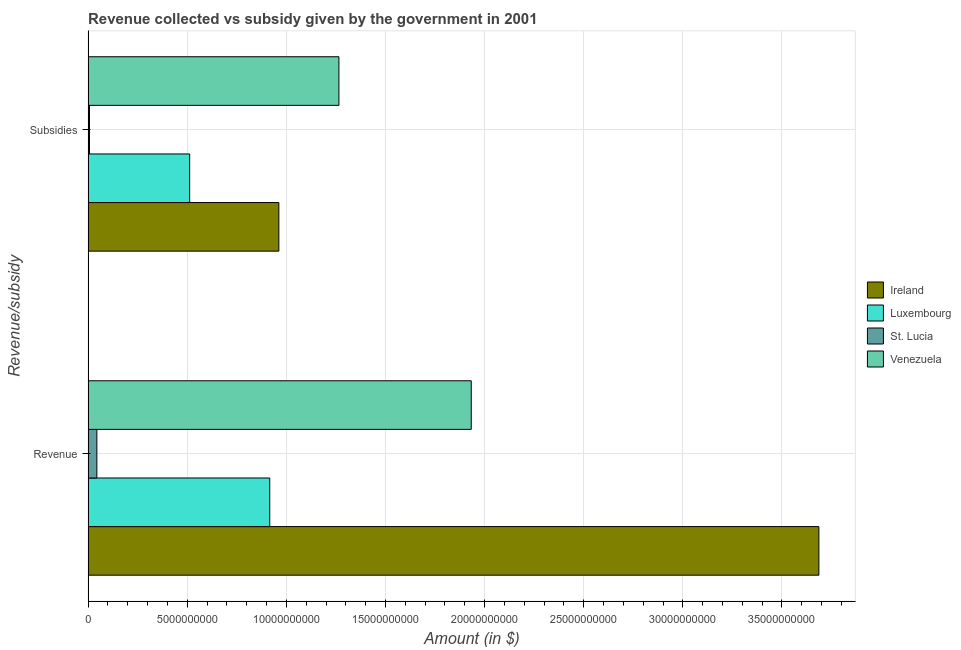How many different coloured bars are there?
Provide a short and direct response. 4. How many groups of bars are there?
Your answer should be very brief. 2. Are the number of bars on each tick of the Y-axis equal?
Your answer should be compact. Yes. How many bars are there on the 2nd tick from the bottom?
Make the answer very short. 4. What is the label of the 1st group of bars from the top?
Offer a very short reply. Subsidies. What is the amount of revenue collected in Luxembourg?
Provide a succinct answer. 9.16e+09. Across all countries, what is the maximum amount of subsidies given?
Keep it short and to the point. 1.27e+1. Across all countries, what is the minimum amount of revenue collected?
Give a very brief answer. 4.42e+08. In which country was the amount of revenue collected maximum?
Offer a very short reply. Ireland. In which country was the amount of subsidies given minimum?
Make the answer very short. St. Lucia. What is the total amount of subsidies given in the graph?
Your answer should be compact. 2.75e+1. What is the difference between the amount of subsidies given in Venezuela and that in St. Lucia?
Make the answer very short. 1.26e+1. What is the difference between the amount of revenue collected in Ireland and the amount of subsidies given in St. Lucia?
Your answer should be very brief. 3.68e+1. What is the average amount of revenue collected per country?
Keep it short and to the point. 1.64e+1. What is the difference between the amount of revenue collected and amount of subsidies given in Venezuela?
Provide a short and direct response. 6.67e+09. In how many countries, is the amount of subsidies given greater than 22000000000 $?
Keep it short and to the point. 0. What is the ratio of the amount of subsidies given in Venezuela to that in Ireland?
Keep it short and to the point. 1.31. What does the 4th bar from the top in Revenue represents?
Provide a short and direct response. Ireland. What does the 2nd bar from the bottom in Revenue represents?
Give a very brief answer. Luxembourg. How many bars are there?
Give a very brief answer. 8. How many countries are there in the graph?
Make the answer very short. 4. What is the difference between two consecutive major ticks on the X-axis?
Keep it short and to the point. 5.00e+09. Are the values on the major ticks of X-axis written in scientific E-notation?
Offer a terse response. No. Does the graph contain grids?
Give a very brief answer. Yes. What is the title of the graph?
Keep it short and to the point. Revenue collected vs subsidy given by the government in 2001. What is the label or title of the X-axis?
Your answer should be compact. Amount (in $). What is the label or title of the Y-axis?
Offer a very short reply. Revenue/subsidy. What is the Amount (in $) in Ireland in Revenue?
Offer a very short reply. 3.69e+1. What is the Amount (in $) in Luxembourg in Revenue?
Provide a succinct answer. 9.16e+09. What is the Amount (in $) of St. Lucia in Revenue?
Your answer should be compact. 4.42e+08. What is the Amount (in $) in Venezuela in Revenue?
Offer a very short reply. 1.93e+1. What is the Amount (in $) in Ireland in Subsidies?
Offer a very short reply. 9.62e+09. What is the Amount (in $) in Luxembourg in Subsidies?
Give a very brief answer. 5.12e+09. What is the Amount (in $) of St. Lucia in Subsidies?
Make the answer very short. 7.10e+07. What is the Amount (in $) of Venezuela in Subsidies?
Provide a succinct answer. 1.27e+1. Across all Revenue/subsidy, what is the maximum Amount (in $) of Ireland?
Give a very brief answer. 3.69e+1. Across all Revenue/subsidy, what is the maximum Amount (in $) in Luxembourg?
Keep it short and to the point. 9.16e+09. Across all Revenue/subsidy, what is the maximum Amount (in $) in St. Lucia?
Give a very brief answer. 4.42e+08. Across all Revenue/subsidy, what is the maximum Amount (in $) in Venezuela?
Provide a short and direct response. 1.93e+1. Across all Revenue/subsidy, what is the minimum Amount (in $) in Ireland?
Provide a succinct answer. 9.62e+09. Across all Revenue/subsidy, what is the minimum Amount (in $) in Luxembourg?
Provide a short and direct response. 5.12e+09. Across all Revenue/subsidy, what is the minimum Amount (in $) in St. Lucia?
Offer a very short reply. 7.10e+07. Across all Revenue/subsidy, what is the minimum Amount (in $) in Venezuela?
Keep it short and to the point. 1.27e+1. What is the total Amount (in $) in Ireland in the graph?
Make the answer very short. 4.65e+1. What is the total Amount (in $) of Luxembourg in the graph?
Keep it short and to the point. 1.43e+1. What is the total Amount (in $) in St. Lucia in the graph?
Ensure brevity in your answer.  5.13e+08. What is the total Amount (in $) in Venezuela in the graph?
Provide a short and direct response. 3.20e+1. What is the difference between the Amount (in $) in Ireland in Revenue and that in Subsidies?
Provide a short and direct response. 2.72e+1. What is the difference between the Amount (in $) of Luxembourg in Revenue and that in Subsidies?
Provide a short and direct response. 4.04e+09. What is the difference between the Amount (in $) of St. Lucia in Revenue and that in Subsidies?
Ensure brevity in your answer.  3.71e+08. What is the difference between the Amount (in $) of Venezuela in Revenue and that in Subsidies?
Ensure brevity in your answer.  6.67e+09. What is the difference between the Amount (in $) of Ireland in Revenue and the Amount (in $) of Luxembourg in Subsidies?
Your answer should be very brief. 3.17e+1. What is the difference between the Amount (in $) of Ireland in Revenue and the Amount (in $) of St. Lucia in Subsidies?
Provide a short and direct response. 3.68e+1. What is the difference between the Amount (in $) of Ireland in Revenue and the Amount (in $) of Venezuela in Subsidies?
Ensure brevity in your answer.  2.42e+1. What is the difference between the Amount (in $) of Luxembourg in Revenue and the Amount (in $) of St. Lucia in Subsidies?
Provide a short and direct response. 9.09e+09. What is the difference between the Amount (in $) of Luxembourg in Revenue and the Amount (in $) of Venezuela in Subsidies?
Provide a succinct answer. -3.49e+09. What is the difference between the Amount (in $) of St. Lucia in Revenue and the Amount (in $) of Venezuela in Subsidies?
Offer a very short reply. -1.22e+1. What is the average Amount (in $) of Ireland per Revenue/subsidy?
Your answer should be compact. 2.32e+1. What is the average Amount (in $) of Luxembourg per Revenue/subsidy?
Provide a short and direct response. 7.14e+09. What is the average Amount (in $) of St. Lucia per Revenue/subsidy?
Provide a short and direct response. 2.57e+08. What is the average Amount (in $) in Venezuela per Revenue/subsidy?
Keep it short and to the point. 1.60e+1. What is the difference between the Amount (in $) in Ireland and Amount (in $) in Luxembourg in Revenue?
Offer a very short reply. 2.77e+1. What is the difference between the Amount (in $) of Ireland and Amount (in $) of St. Lucia in Revenue?
Your answer should be compact. 3.64e+1. What is the difference between the Amount (in $) of Ireland and Amount (in $) of Venezuela in Revenue?
Provide a short and direct response. 1.75e+1. What is the difference between the Amount (in $) in Luxembourg and Amount (in $) in St. Lucia in Revenue?
Your response must be concise. 8.72e+09. What is the difference between the Amount (in $) of Luxembourg and Amount (in $) of Venezuela in Revenue?
Your answer should be very brief. -1.02e+1. What is the difference between the Amount (in $) of St. Lucia and Amount (in $) of Venezuela in Revenue?
Your answer should be compact. -1.89e+1. What is the difference between the Amount (in $) in Ireland and Amount (in $) in Luxembourg in Subsidies?
Keep it short and to the point. 4.50e+09. What is the difference between the Amount (in $) in Ireland and Amount (in $) in St. Lucia in Subsidies?
Offer a very short reply. 9.55e+09. What is the difference between the Amount (in $) of Ireland and Amount (in $) of Venezuela in Subsidies?
Keep it short and to the point. -3.03e+09. What is the difference between the Amount (in $) in Luxembourg and Amount (in $) in St. Lucia in Subsidies?
Offer a very short reply. 5.05e+09. What is the difference between the Amount (in $) of Luxembourg and Amount (in $) of Venezuela in Subsidies?
Your answer should be very brief. -7.53e+09. What is the difference between the Amount (in $) of St. Lucia and Amount (in $) of Venezuela in Subsidies?
Your response must be concise. -1.26e+1. What is the ratio of the Amount (in $) in Ireland in Revenue to that in Subsidies?
Your answer should be very brief. 3.83. What is the ratio of the Amount (in $) in Luxembourg in Revenue to that in Subsidies?
Provide a short and direct response. 1.79. What is the ratio of the Amount (in $) in St. Lucia in Revenue to that in Subsidies?
Make the answer very short. 6.23. What is the ratio of the Amount (in $) of Venezuela in Revenue to that in Subsidies?
Provide a short and direct response. 1.53. What is the difference between the highest and the second highest Amount (in $) of Ireland?
Offer a very short reply. 2.72e+1. What is the difference between the highest and the second highest Amount (in $) of Luxembourg?
Make the answer very short. 4.04e+09. What is the difference between the highest and the second highest Amount (in $) in St. Lucia?
Your answer should be compact. 3.71e+08. What is the difference between the highest and the second highest Amount (in $) in Venezuela?
Your answer should be very brief. 6.67e+09. What is the difference between the highest and the lowest Amount (in $) in Ireland?
Offer a very short reply. 2.72e+1. What is the difference between the highest and the lowest Amount (in $) in Luxembourg?
Ensure brevity in your answer.  4.04e+09. What is the difference between the highest and the lowest Amount (in $) of St. Lucia?
Provide a short and direct response. 3.71e+08. What is the difference between the highest and the lowest Amount (in $) in Venezuela?
Your answer should be very brief. 6.67e+09. 